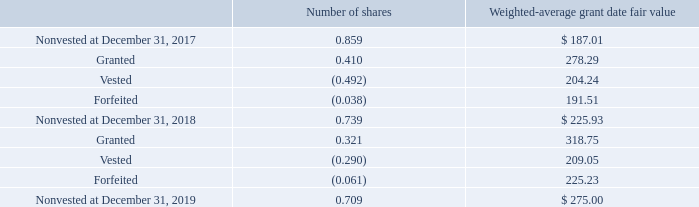Restricted Stock Grants—During 2019 and 2018, the Company granted 0.321 and 0.410 shares, respectively, of restricted stock to certain employee and director participants under its share-based compensation plans. Restricted stock grants generally vest over a period of 1 to 4 years. The Company recorded $72.5, $109.7 and $63.0 of compensation expense related to outstanding shares of restricted stock held by employees and directors during 2019, 2018 and 2017, respectively. In 2018, this expense included $29.4 associated with accelerated vesting due to the passing of our former executive chairman. A summary of the Company’s nonvested shares activity for 2019 and 2018 is as follows:
At December 31, 2019, there was $77.9 of total unrecognized compensation expense related to nonvested awards granted to both employees and directors under the Company’s share-based compensation plans. That cost is expected to be recognized over a weighted-average period of 1.8 years. Unrecognized compensation expense related to nonvested shares of restricted stock grants is recorded as a reduction to additional paid-in capital in stockholder’s equity at December 31, 2019.
Employee Stock Purchase Plan—During 2019, 2018 and 2017, participants of the ESPP purchased 0.021, 0.020 and 0.020 shares, respectively, of Roper’s common stock for total consideration of $6.8, $5.4, and $4.2, respectively. All of these shares were purchased from Roper’s treasury shares.
What was the compensation expense related to outstanding shares of restricted stock held by employees and directors during 2019? $72.5. How long does restricted stock grants generally vest over? A period of 1 to 4 years. What was the total unrecognized compensation expense related to nonvested awards granted during fiscal 2019? $77.9. What is the ratio of compensation expense related to outstanding shares of restricted stock during 2018 to the total price of restricted stock shares granted between 2017 and 2018?  109.7/(0.41*278.29) 
Answer: 0.96. What is the percentage change in the total price of nonvested shares from December 31, 2018, to 2019?
Answer scale should be: percent. ((0.709*275.00)-(0.739*225.93))/(0.739*225.93) 
Answer: 16.78. What is the total price of shares that were forfeited between 2018 and 2019?
Answer scale should be: million. 0.061*225.23 
Answer: 13.74. 